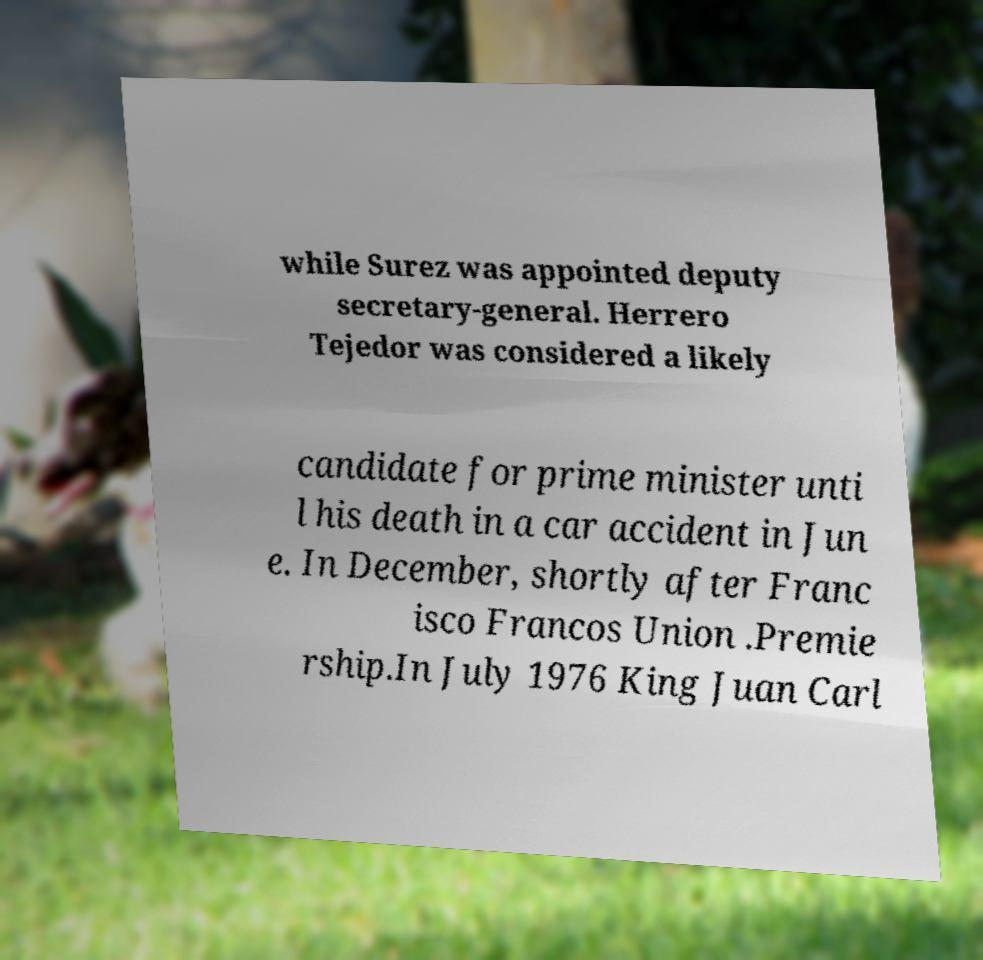Please identify and transcribe the text found in this image. while Surez was appointed deputy secretary-general. Herrero Tejedor was considered a likely candidate for prime minister unti l his death in a car accident in Jun e. In December, shortly after Franc isco Francos Union .Premie rship.In July 1976 King Juan Carl 